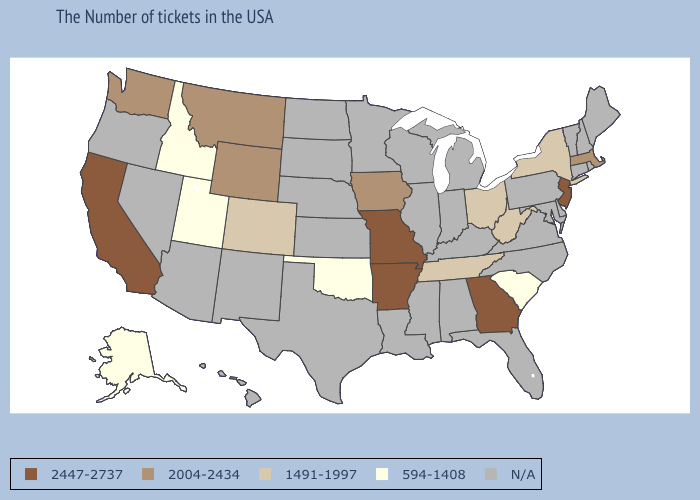Does Missouri have the highest value in the USA?
Write a very short answer. Yes. Is the legend a continuous bar?
Quick response, please. No. Does the first symbol in the legend represent the smallest category?
Be succinct. No. Is the legend a continuous bar?
Answer briefly. No. What is the value of Kansas?
Be succinct. N/A. Does Wyoming have the lowest value in the West?
Keep it brief. No. What is the value of West Virginia?
Answer briefly. 1491-1997. What is the value of New York?
Write a very short answer. 1491-1997. What is the lowest value in states that border Louisiana?
Concise answer only. 2447-2737. Does Tennessee have the lowest value in the USA?
Keep it brief. No. Does New York have the highest value in the USA?
Give a very brief answer. No. Does the first symbol in the legend represent the smallest category?
Keep it brief. No. Does the first symbol in the legend represent the smallest category?
Concise answer only. No. 